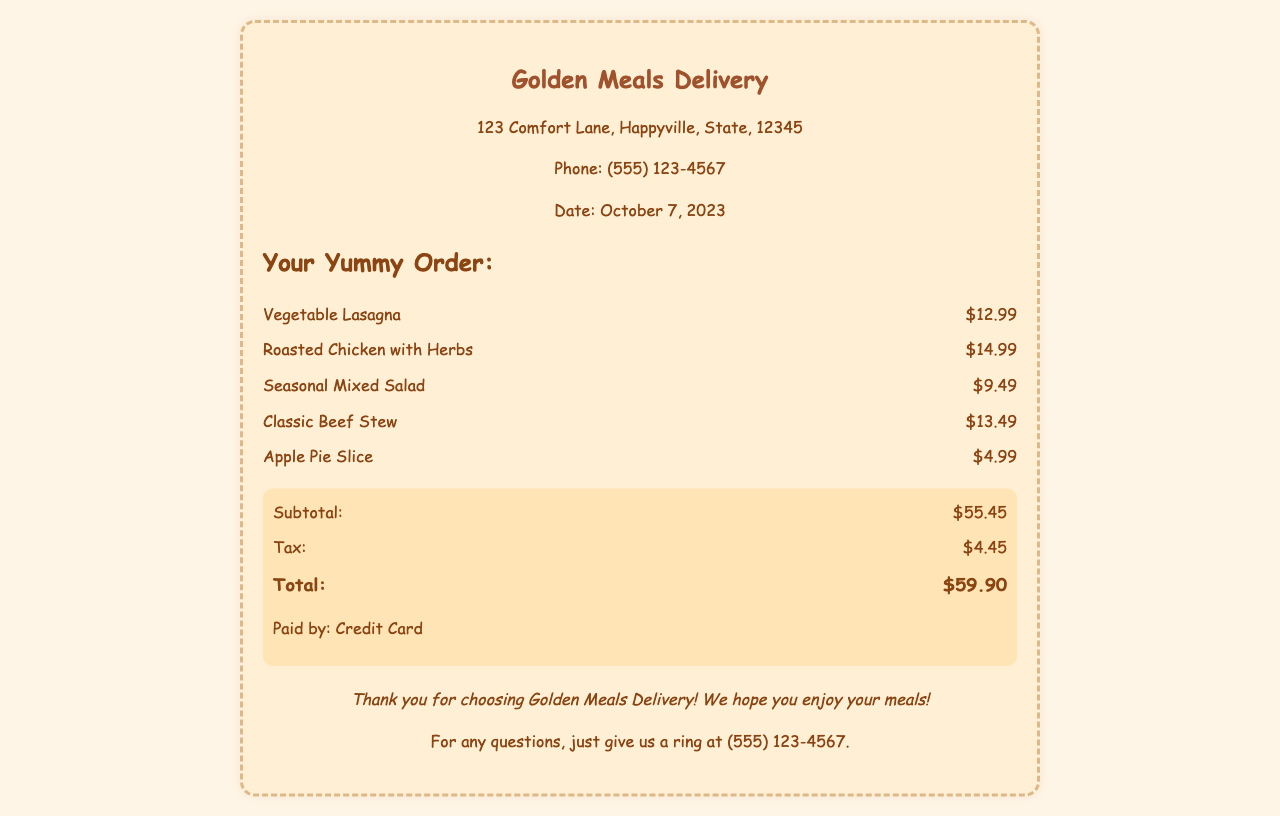What is the name of the meal delivery service? The name of the meal delivery service is listed at the top of the receipt.
Answer: Golden Meals Delivery What date is the receipt for? The date of the order is shown in the header section of the receipt.
Answer: October 7, 2023 How much did the Vegetable Lasagna cost? The cost of the Vegetable Lasagna is displayed next to its name in the order details.
Answer: $12.99 What is the subtotal of the order? The subtotal is a specific line item in the summary section of the receipt.
Answer: $55.45 What is the total amount paid? The total amount is highlighted in the summary section as the final charge for the order.
Answer: $59.90 How much was charged for tax? The tax amount is separately noted in the summary and calculated as part of the total.
Answer: $4.45 What was the last item ordered? The last item listed in the order details is the one furthest down the list.
Answer: Apple Pie Slice What payment method was used? The method of payment is provided in the summary section near the total.
Answer: Credit Card How many items were ordered in total? The total count of items can be deduced by manually counting each listed dish on the receipt.
Answer: 5 